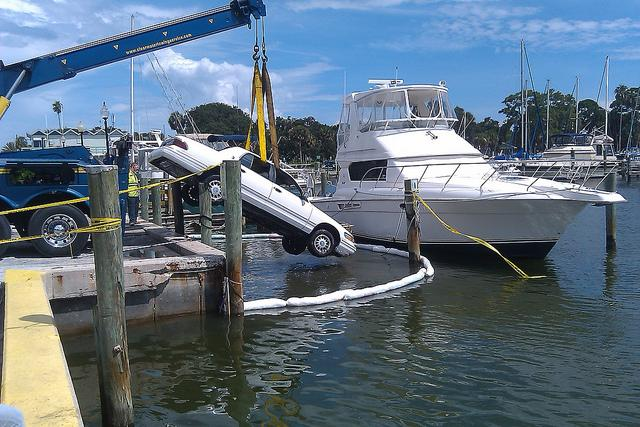Where has the white car on the yellow straps been?

Choices:
A) harbor water
B) towtruck bed
C) boat
D) dock harbor water 